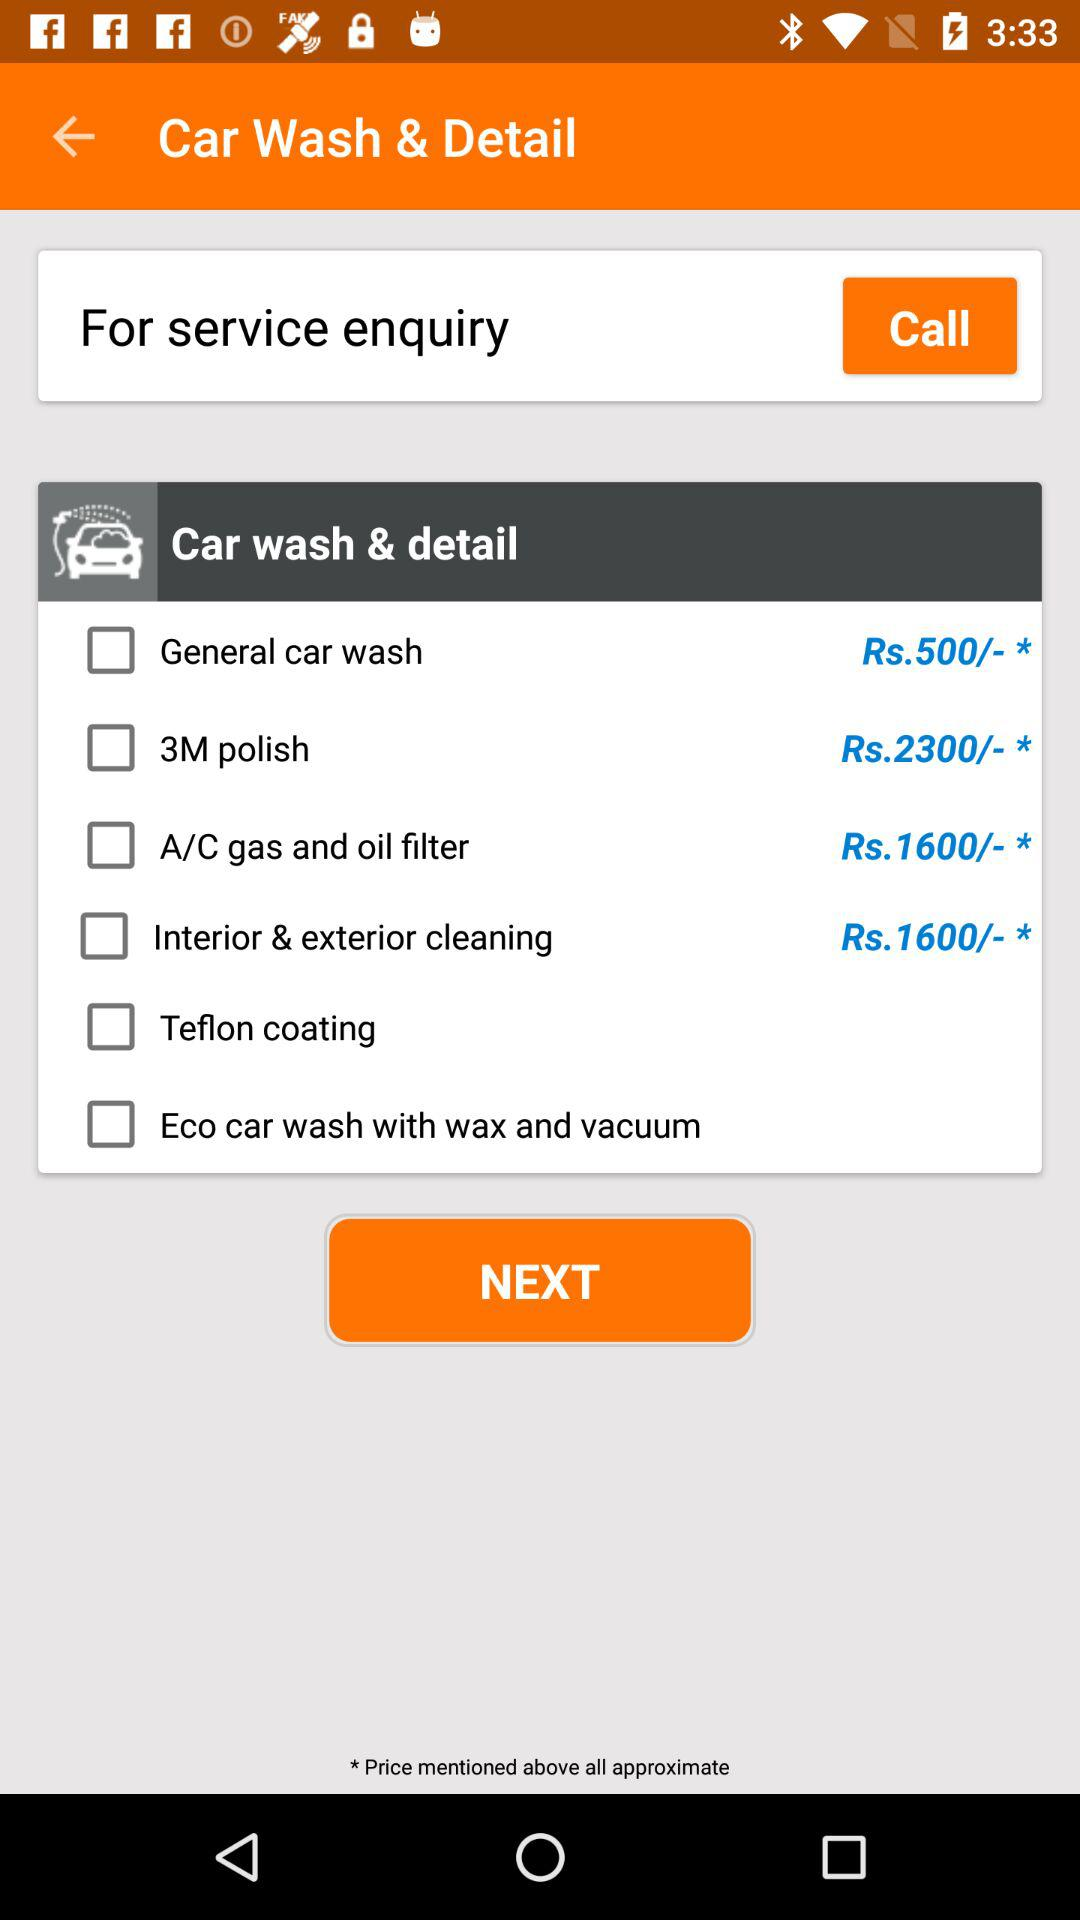What is the cost of "3M polish"? The cost of "3M polish" is Rs. 2300. 